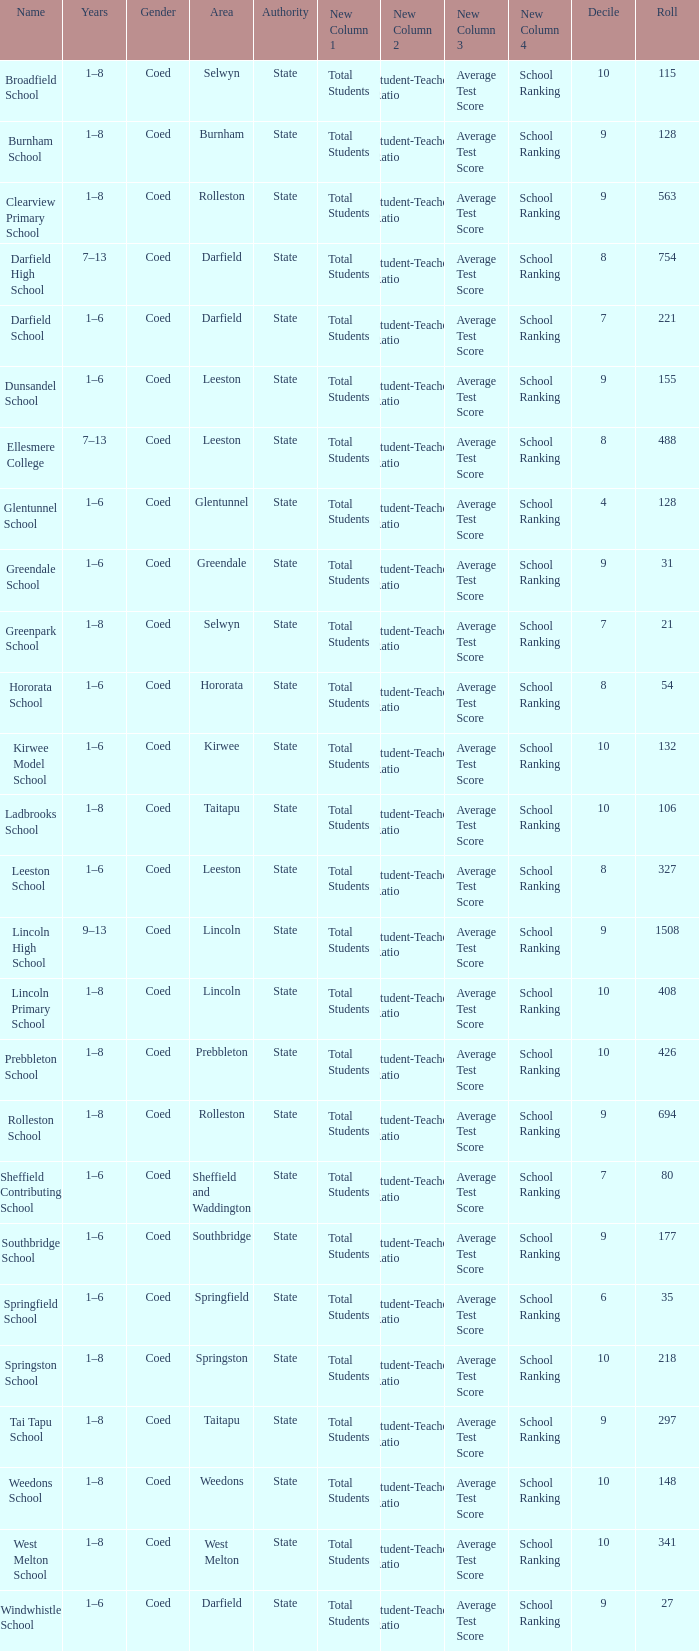How many deciles have Years of 9–13? 1.0. 